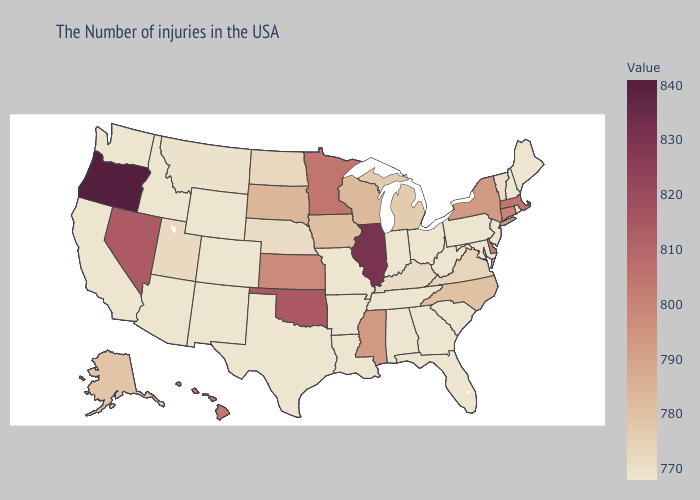Does Wisconsin have the lowest value in the USA?
Keep it brief. No. Does Vermont have the lowest value in the Northeast?
Give a very brief answer. No. Is the legend a continuous bar?
Quick response, please. Yes. Which states hav the highest value in the MidWest?
Be succinct. Illinois. Is the legend a continuous bar?
Give a very brief answer. Yes. 